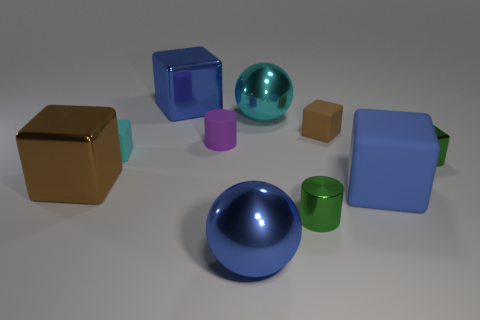Subtract all green cubes. How many cubes are left? 5 Subtract all blue metallic cubes. How many cubes are left? 5 Subtract all cyan blocks. Subtract all purple balls. How many blocks are left? 5 Subtract all cylinders. How many objects are left? 8 Add 3 purple objects. How many purple objects exist? 4 Subtract 0 purple spheres. How many objects are left? 10 Subtract all tiny cubes. Subtract all cyan metal spheres. How many objects are left? 6 Add 7 green shiny blocks. How many green shiny blocks are left? 8 